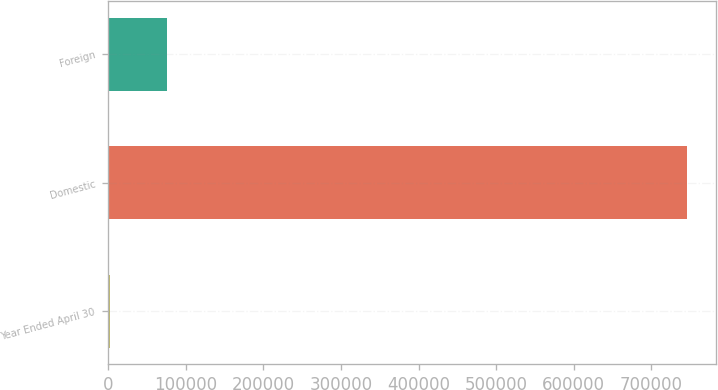<chart> <loc_0><loc_0><loc_500><loc_500><bar_chart><fcel>Year Ended April 30<fcel>Domestic<fcel>Foreign<nl><fcel>2010<fcel>745912<fcel>76400.2<nl></chart> 